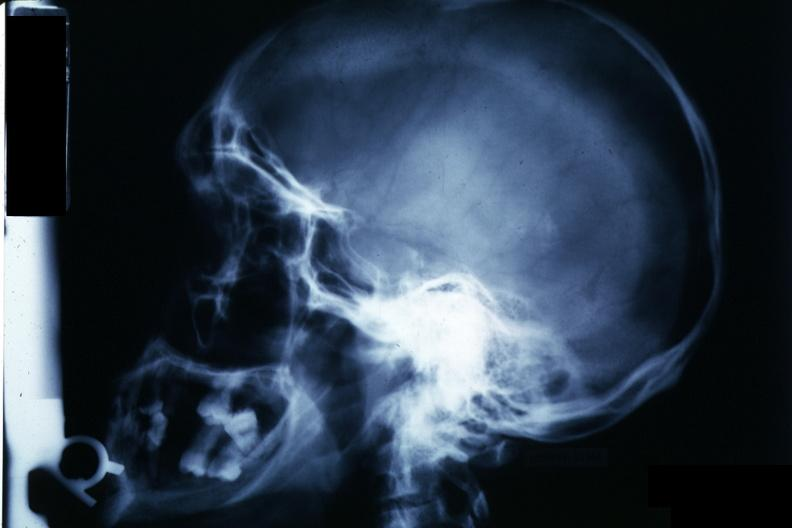does papillary adenoma show x-ray sella?
Answer the question using a single word or phrase. No 